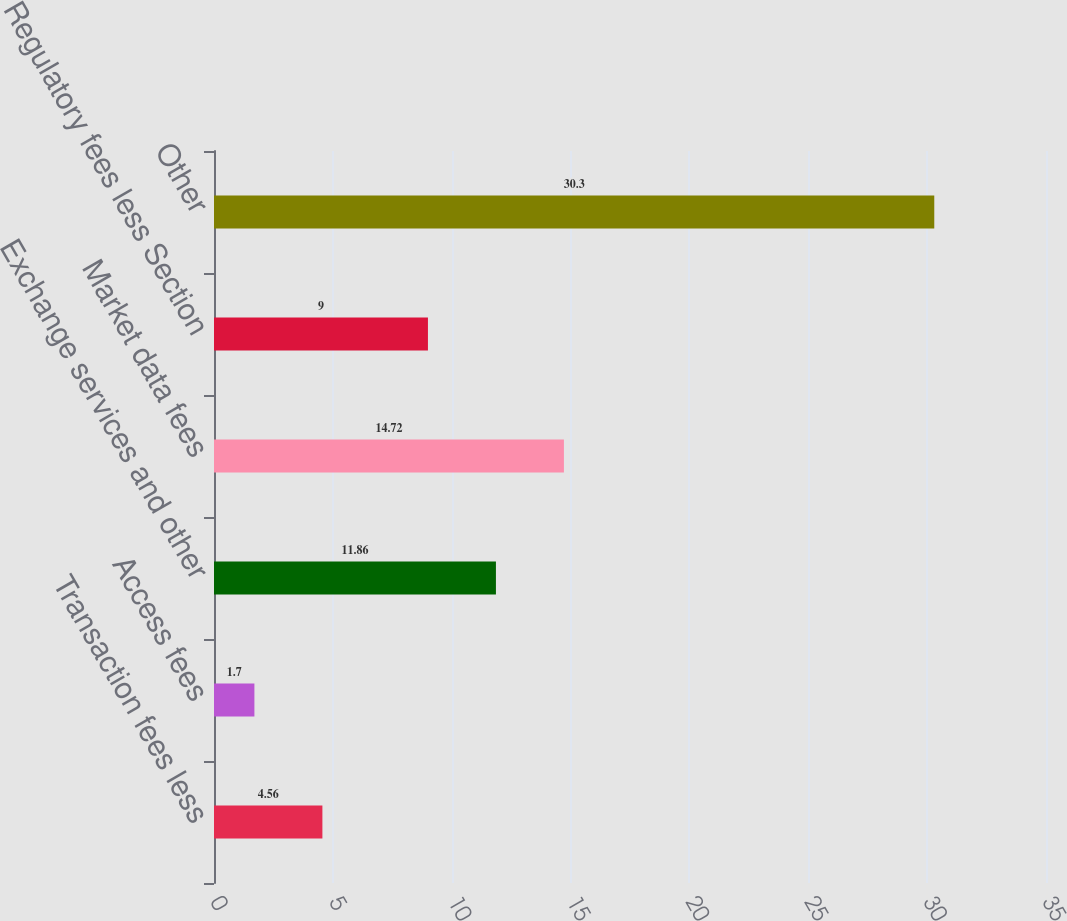Convert chart to OTSL. <chart><loc_0><loc_0><loc_500><loc_500><bar_chart><fcel>Transaction fees less<fcel>Access fees<fcel>Exchange services and other<fcel>Market data fees<fcel>Regulatory fees less Section<fcel>Other<nl><fcel>4.56<fcel>1.7<fcel>11.86<fcel>14.72<fcel>9<fcel>30.3<nl></chart> 